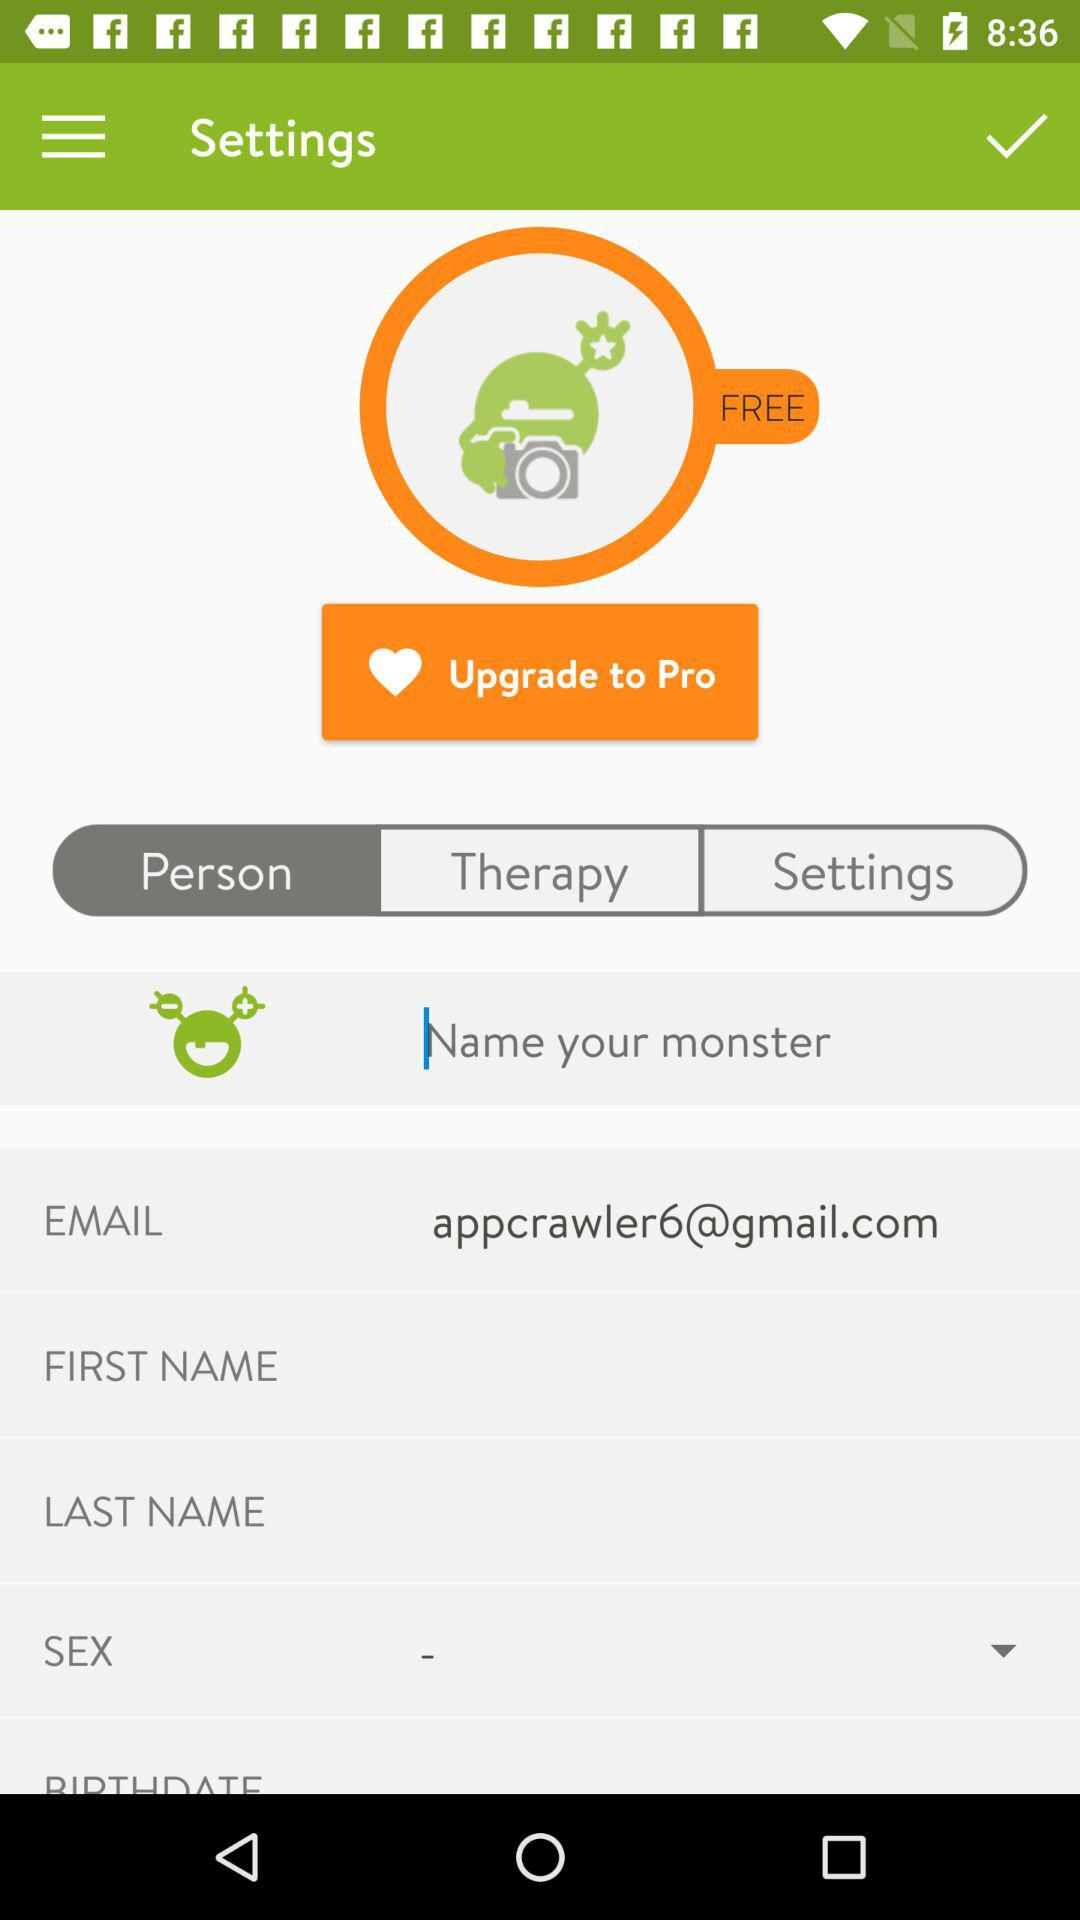Which is the currently selected tab? The currently selected tab is "Person". 